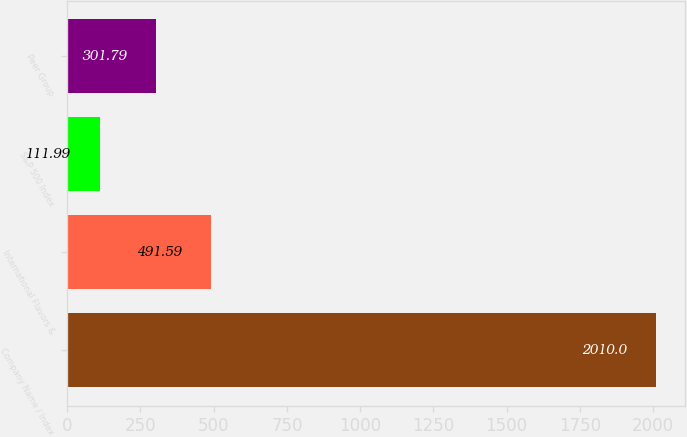<chart> <loc_0><loc_0><loc_500><loc_500><bar_chart><fcel>Company Name / Index<fcel>International Flavors &<fcel>S&P 500 Index<fcel>Peer Group<nl><fcel>2010<fcel>491.59<fcel>111.99<fcel>301.79<nl></chart> 